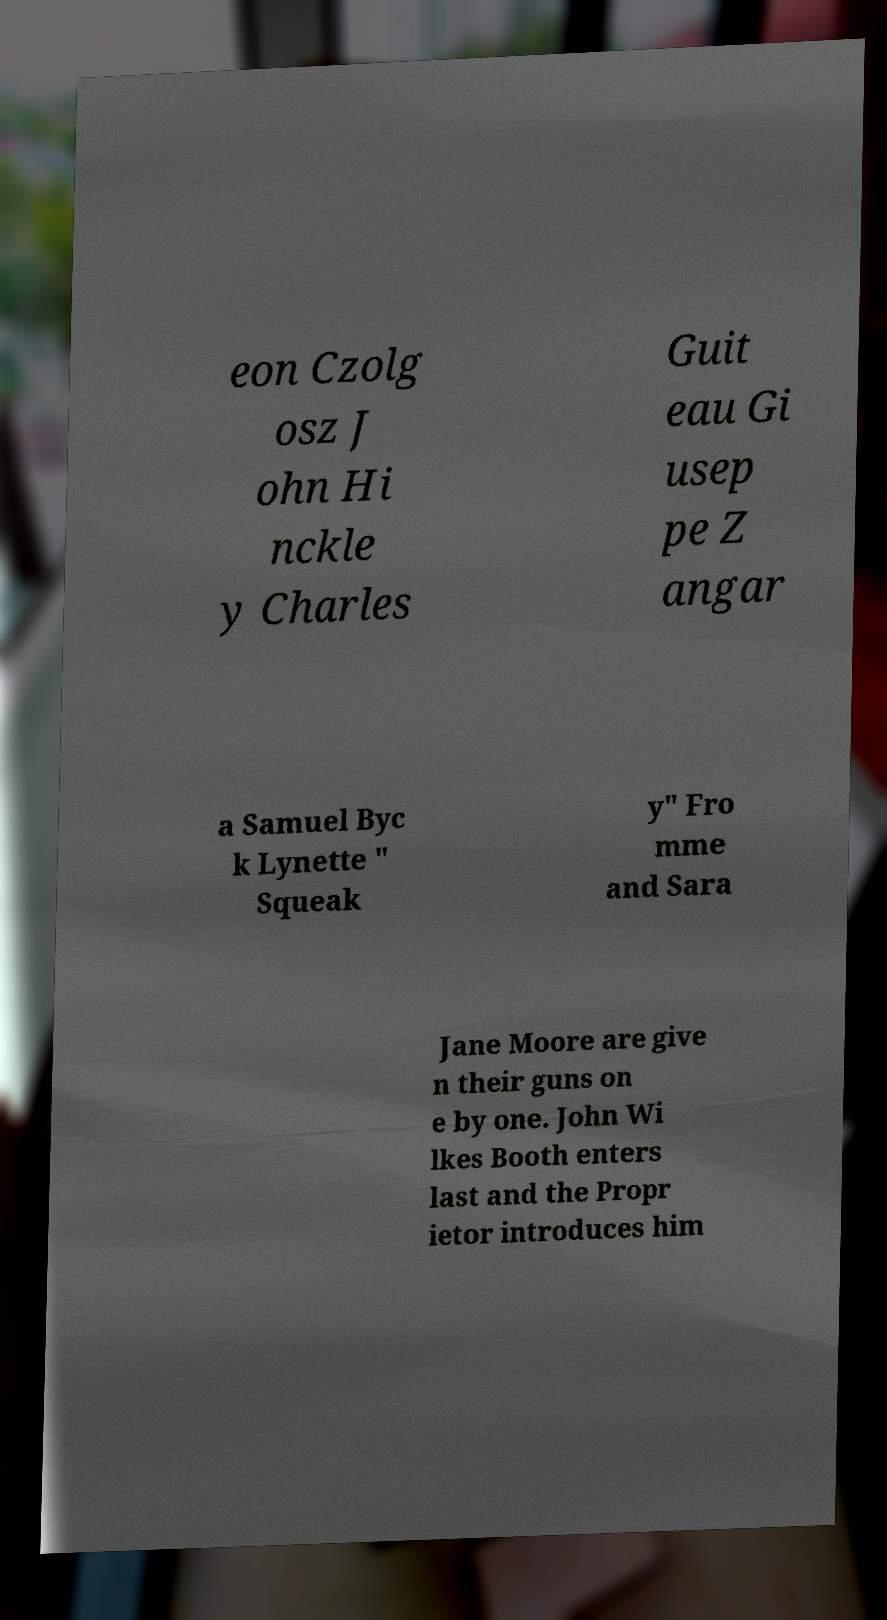Could you assist in decoding the text presented in this image and type it out clearly? eon Czolg osz J ohn Hi nckle y Charles Guit eau Gi usep pe Z angar a Samuel Byc k Lynette " Squeak y" Fro mme and Sara Jane Moore are give n their guns on e by one. John Wi lkes Booth enters last and the Propr ietor introduces him 